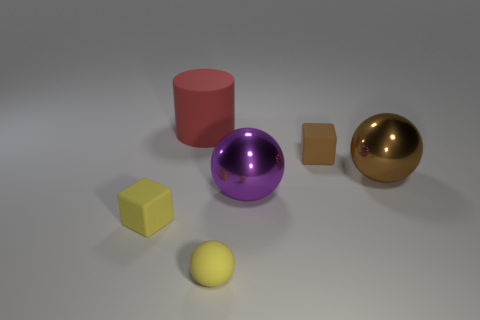The tiny block to the right of the cube that is left of the large red matte thing is made of what material?
Offer a terse response. Rubber. Do the brown rubber block and the cylinder have the same size?
Your response must be concise. No. How many big things are either matte balls or gray shiny blocks?
Provide a short and direct response. 0. What number of small yellow cubes are behind the rubber sphere?
Offer a terse response. 1. Are there more big red cylinders that are behind the yellow matte sphere than blue shiny spheres?
Make the answer very short. Yes. What shape is the big red thing that is made of the same material as the brown block?
Offer a very short reply. Cylinder. There is a small object behind the matte cube to the left of the brown block; what is its color?
Provide a short and direct response. Brown. Is the big purple shiny thing the same shape as the big brown thing?
Your answer should be compact. Yes. There is a yellow thing that is the same shape as the big purple thing; what is it made of?
Your answer should be very brief. Rubber. Is there a small cube that is left of the purple ball right of the matte object that is to the left of the big cylinder?
Make the answer very short. Yes. 